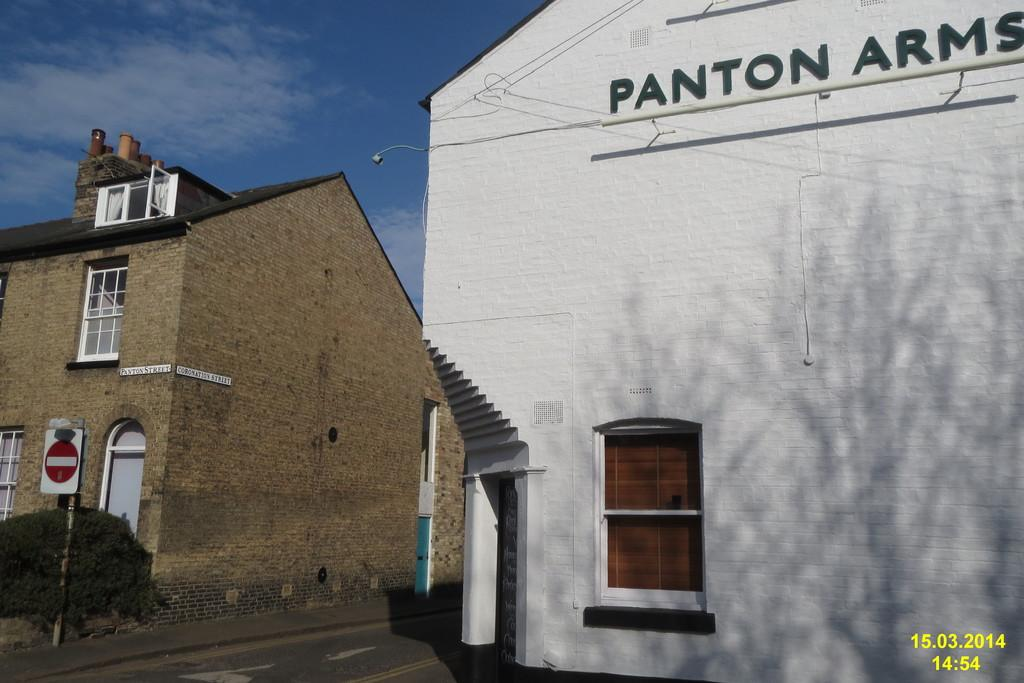<image>
Offer a succinct explanation of the picture presented. a white building Panton Arms sits by a dead end road 